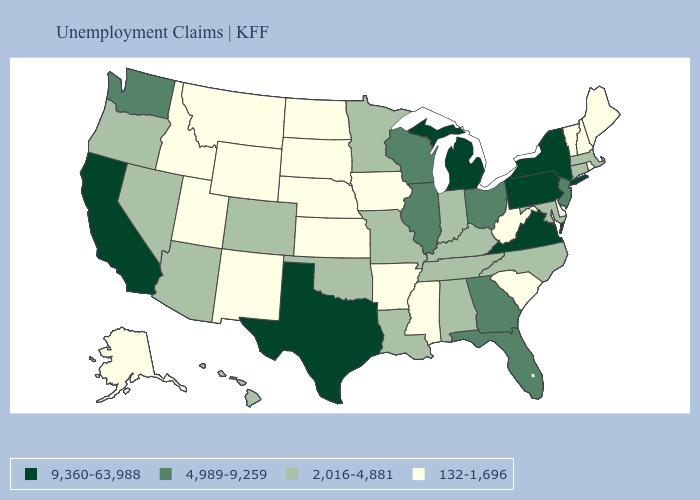Name the states that have a value in the range 9,360-63,988?
Be succinct. California, Michigan, New York, Pennsylvania, Texas, Virginia. Does North Carolina have the same value as Arizona?
Short answer required. Yes. Does Texas have the highest value in the South?
Be succinct. Yes. Which states have the highest value in the USA?
Concise answer only. California, Michigan, New York, Pennsylvania, Texas, Virginia. Is the legend a continuous bar?
Write a very short answer. No. What is the value of Oregon?
Quick response, please. 2,016-4,881. Name the states that have a value in the range 4,989-9,259?
Concise answer only. Florida, Georgia, Illinois, New Jersey, Ohio, Washington, Wisconsin. Name the states that have a value in the range 2,016-4,881?
Answer briefly. Alabama, Arizona, Colorado, Connecticut, Hawaii, Indiana, Kentucky, Louisiana, Maryland, Massachusetts, Minnesota, Missouri, Nevada, North Carolina, Oklahoma, Oregon, Tennessee. Does Idaho have a lower value than Utah?
Concise answer only. No. Is the legend a continuous bar?
Be succinct. No. What is the lowest value in the USA?
Answer briefly. 132-1,696. Name the states that have a value in the range 9,360-63,988?
Give a very brief answer. California, Michigan, New York, Pennsylvania, Texas, Virginia. What is the lowest value in the USA?
Keep it brief. 132-1,696. What is the value of Indiana?
Keep it brief. 2,016-4,881. 